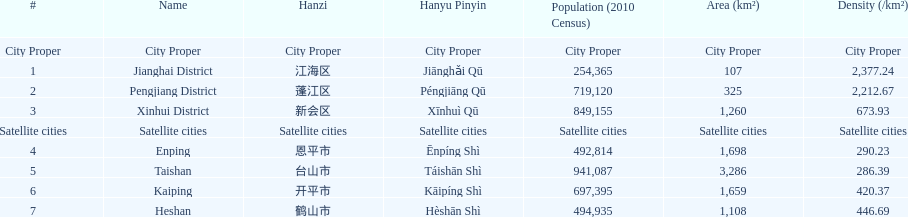Among the satellite cities, which area has the greatest population? Taishan. 